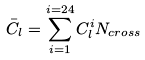<formula> <loc_0><loc_0><loc_500><loc_500>\bar { C } _ { l } = \sum _ { i = 1 } ^ { i = 2 4 } C _ { l } ^ { i } N _ { c r o s s }</formula> 